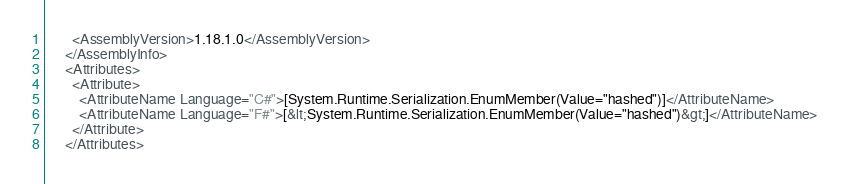Convert code to text. <code><loc_0><loc_0><loc_500><loc_500><_XML_>        <AssemblyVersion>1.18.1.0</AssemblyVersion>
      </AssemblyInfo>
      <Attributes>
        <Attribute>
          <AttributeName Language="C#">[System.Runtime.Serialization.EnumMember(Value="hashed")]</AttributeName>
          <AttributeName Language="F#">[&lt;System.Runtime.Serialization.EnumMember(Value="hashed")&gt;]</AttributeName>
        </Attribute>
      </Attributes></code> 